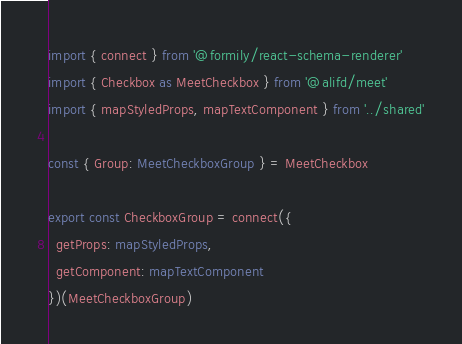<code> <loc_0><loc_0><loc_500><loc_500><_TypeScript_>import { connect } from '@formily/react-schema-renderer'
import { Checkbox as MeetCheckbox } from '@alifd/meet'
import { mapStyledProps, mapTextComponent } from '../shared'

const { Group: MeetCheckboxGroup } = MeetCheckbox

export const CheckboxGroup = connect({
  getProps: mapStyledProps,
  getComponent: mapTextComponent
})(MeetCheckboxGroup)

</code> 